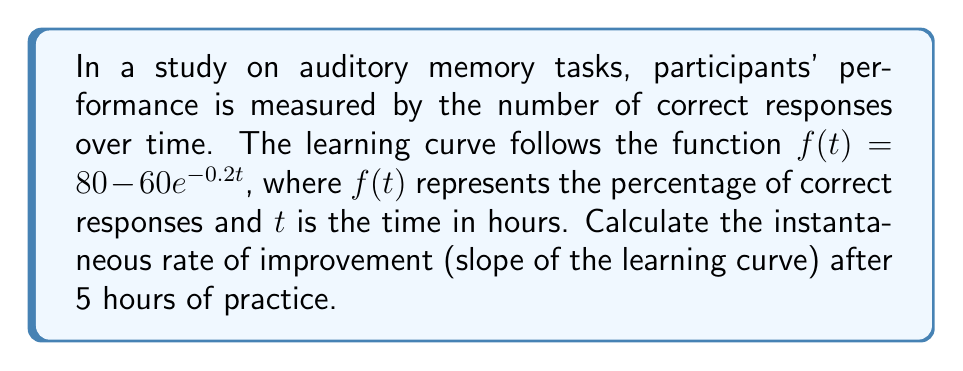What is the answer to this math problem? To find the slope of the learning curve at a specific point, we need to calculate the derivative of the function and evaluate it at the given time.

1. The given function is $f(t) = 80 - 60e^{-0.2t}$

2. To find the derivative, we use the chain rule:
   $$f'(t) = 0 - 60 \cdot (-0.2e^{-0.2t})$$
   $$f'(t) = 12e^{-0.2t}$$

3. Now we need to evaluate $f'(t)$ at $t = 5$:
   $$f'(5) = 12e^{-0.2(5)}$$
   $$f'(5) = 12e^{-1}$$

4. Calculate the final value:
   $$f'(5) = 12 \cdot 0.3679 \approx 4.4148$$

The slope of the learning curve after 5 hours of practice is approximately 4.4148 percentage points per hour.
Answer: $4.4148$ percentage points per hour 